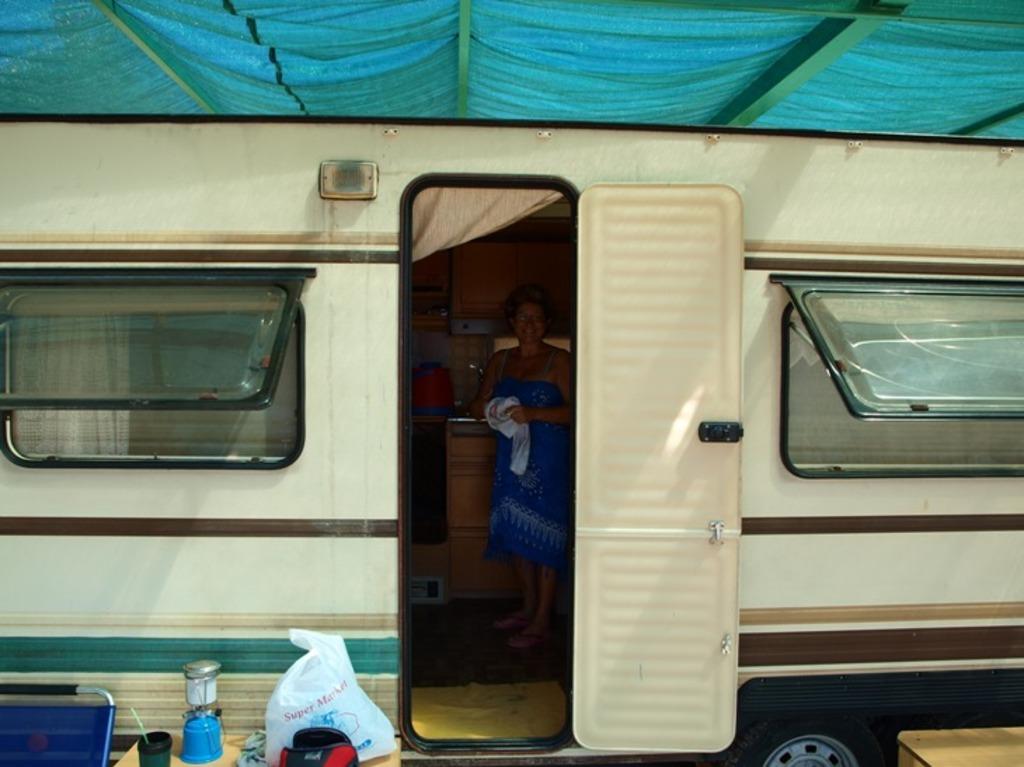Describe this image in one or two sentences. In this picture we can see cover and objects on the table and we can see windows. There is a woman standing inside of a vehicle and holding a cloth, behind her we can see water can on the platform and cupboards. At the top of the image we can see blue cloth. 